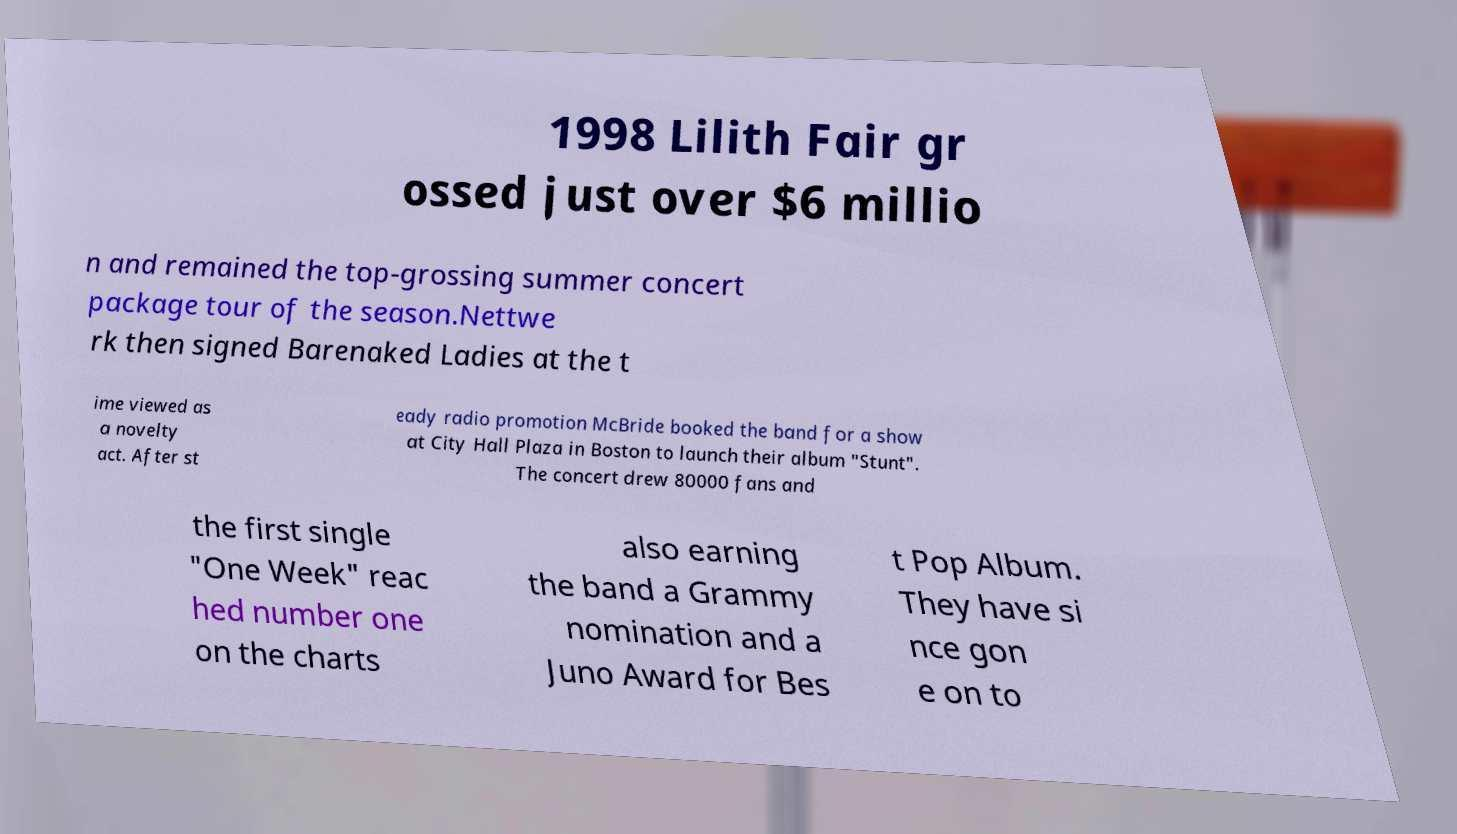What messages or text are displayed in this image? I need them in a readable, typed format. 1998 Lilith Fair gr ossed just over $6 millio n and remained the top-grossing summer concert package tour of the season.Nettwe rk then signed Barenaked Ladies at the t ime viewed as a novelty act. After st eady radio promotion McBride booked the band for a show at City Hall Plaza in Boston to launch their album "Stunt". The concert drew 80000 fans and the first single "One Week" reac hed number one on the charts also earning the band a Grammy nomination and a Juno Award for Bes t Pop Album. They have si nce gon e on to 